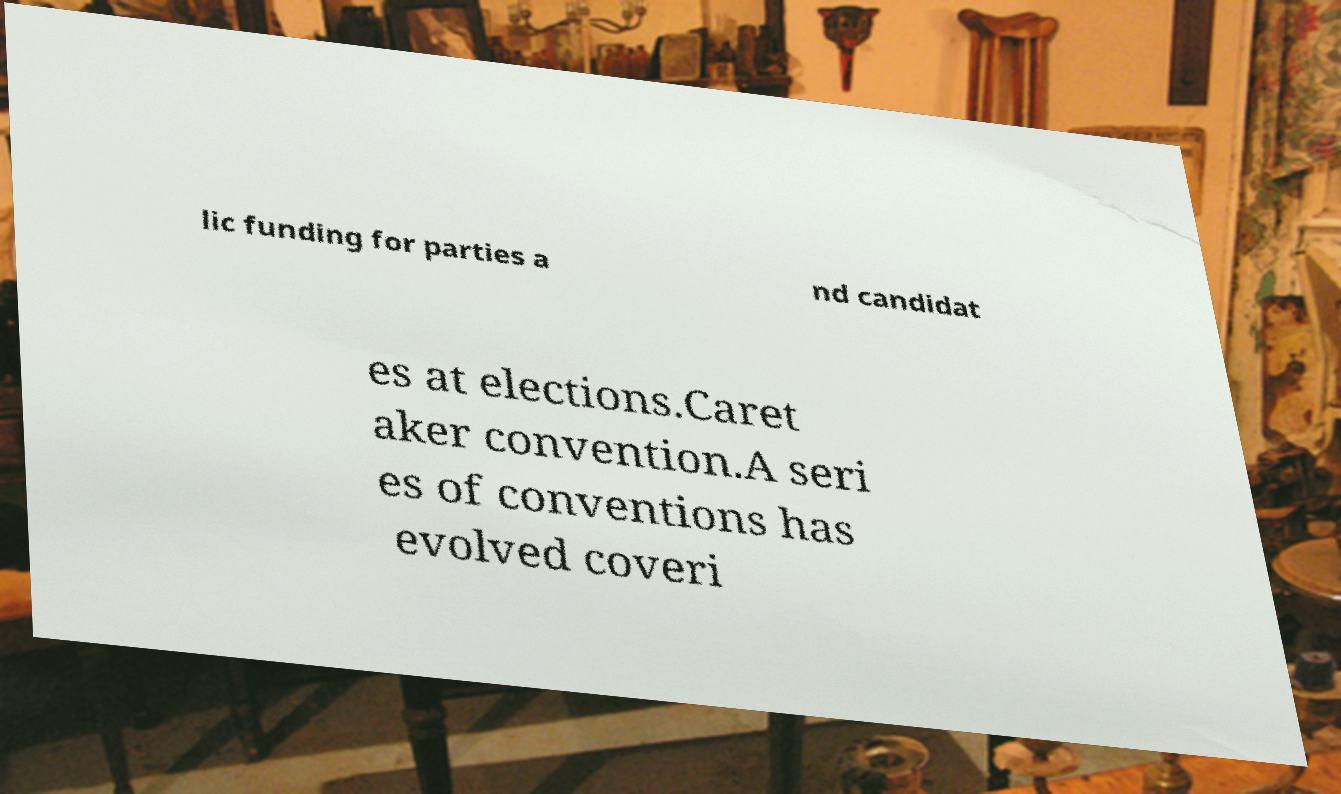Can you read and provide the text displayed in the image?This photo seems to have some interesting text. Can you extract and type it out for me? lic funding for parties a nd candidat es at elections.Caret aker convention.A seri es of conventions has evolved coveri 